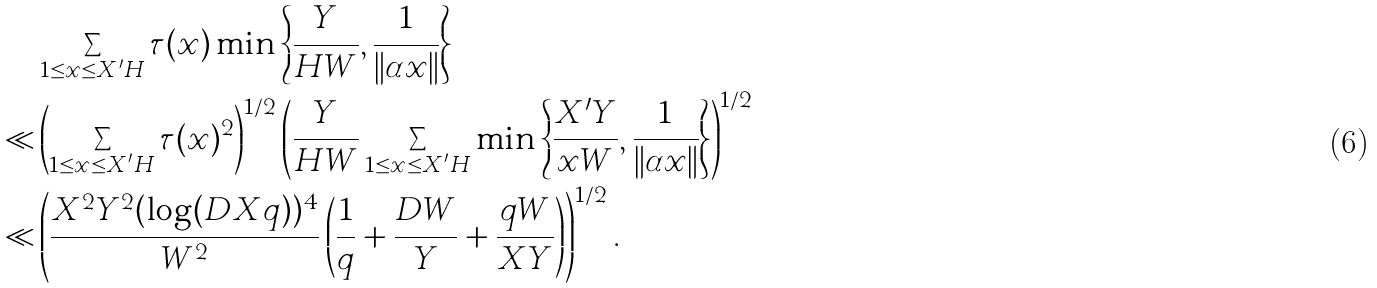Convert formula to latex. <formula><loc_0><loc_0><loc_500><loc_500>& \sum _ { \substack { 1 \leq x \leq X ^ { \prime } H } } \tau ( x ) \min \left \{ \frac { Y } { H W } , \frac { 1 } { \| \alpha x \| } \right \} \\ \ll & \left ( \sum _ { \substack { 1 \leq x \leq X ^ { \prime } H } } \tau ( x ) ^ { 2 } \right ) ^ { 1 / 2 } \left ( \frac { Y } { H W } \sum _ { \substack { 1 \leq x \leq X ^ { \prime } H } } \min \left \{ \frac { X ^ { \prime } Y } { x W } , \frac { 1 } { \| \alpha x \| } \right \} \right ) ^ { 1 / 2 } \\ \ll & \left ( \frac { X ^ { 2 } Y ^ { 2 } ( \log ( D X q ) ) ^ { 4 } } { W ^ { 2 } } \left ( \frac { 1 } { q } + \frac { D W } { Y } + \frac { q W } { X Y } \right ) \right ) ^ { 1 / 2 } .</formula> 